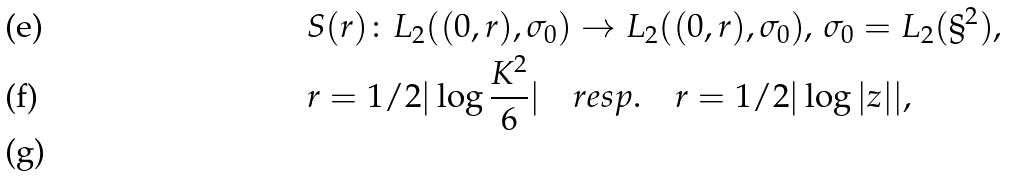Convert formula to latex. <formula><loc_0><loc_0><loc_500><loc_500>& { S } ( { r } ) \colon L _ { 2 } ( ( 0 , { r } ) , { \sigma _ { 0 } } ) \to L _ { 2 } ( ( 0 , { r } ) , { \sigma _ { 0 } } ) , \, { \sigma _ { 0 } } = L _ { 2 } ( \S ^ { 2 } ) , \\ & { r } = 1 / 2 | \log \frac { K ^ { 2 } } { 6 } | \quad r e s p . \quad r = 1 / 2 | \log | z | | , \\</formula> 